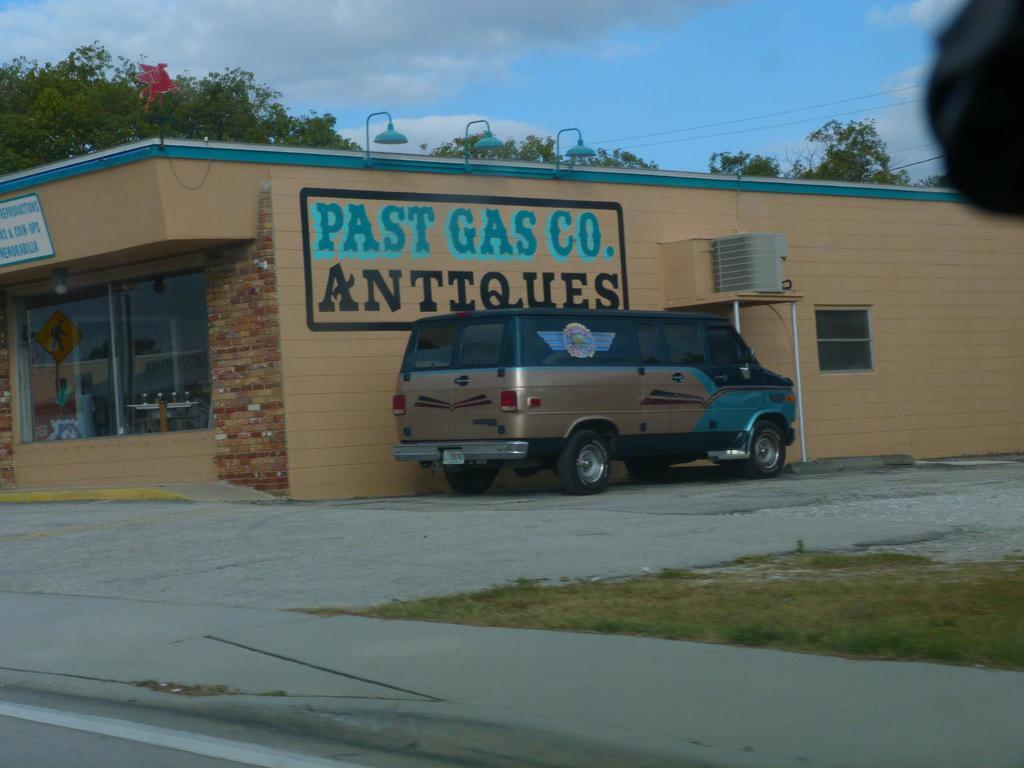<image>
Describe the image concisely. A van sits in a front of a building that says Past Gas Co. Antiques 